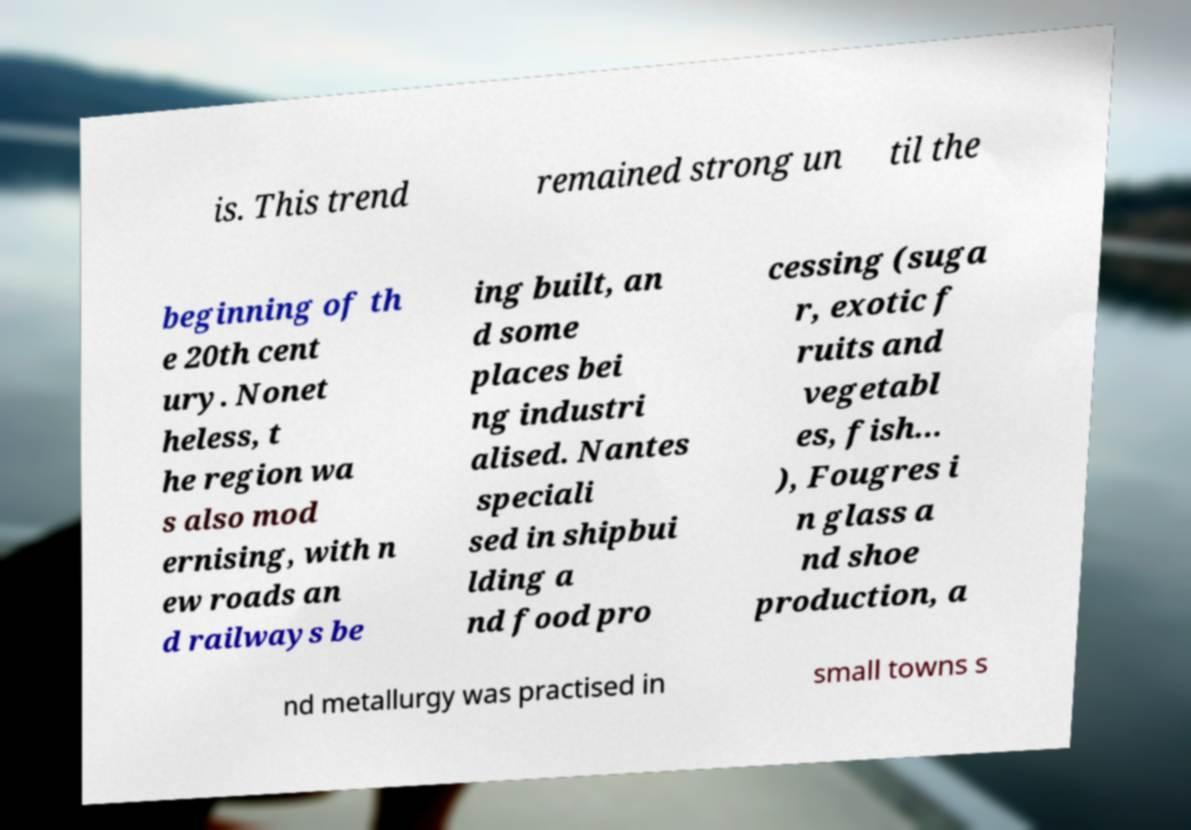What messages or text are displayed in this image? I need them in a readable, typed format. is. This trend remained strong un til the beginning of th e 20th cent ury. Nonet heless, t he region wa s also mod ernising, with n ew roads an d railways be ing built, an d some places bei ng industri alised. Nantes speciali sed in shipbui lding a nd food pro cessing (suga r, exotic f ruits and vegetabl es, fish... ), Fougres i n glass a nd shoe production, a nd metallurgy was practised in small towns s 